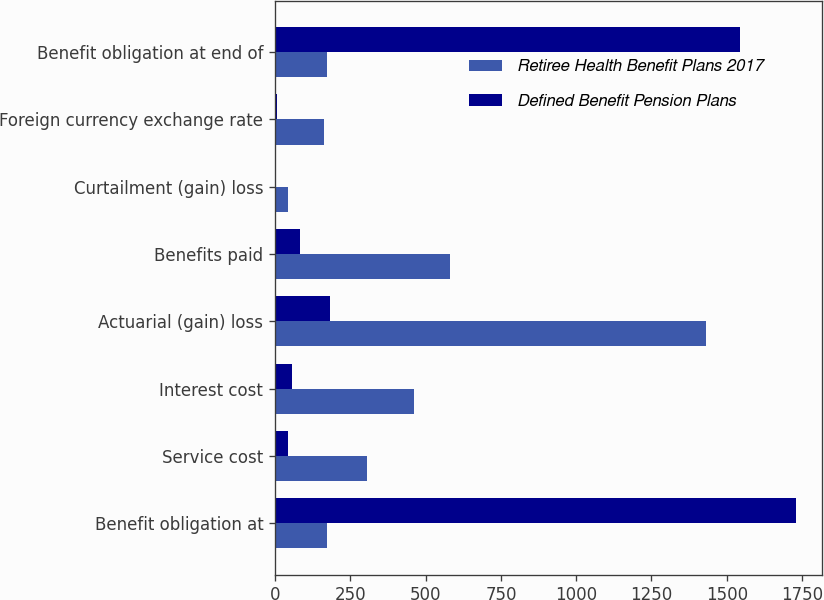<chart> <loc_0><loc_0><loc_500><loc_500><stacked_bar_chart><ecel><fcel>Benefit obligation at<fcel>Service cost<fcel>Interest cost<fcel>Actuarial (gain) loss<fcel>Benefits paid<fcel>Curtailment (gain) loss<fcel>Foreign currency exchange rate<fcel>Benefit obligation at end of<nl><fcel>Retiree Health Benefit Plans 2017<fcel>172.35<fcel>304<fcel>461<fcel>1431.2<fcel>582.1<fcel>43.9<fcel>161.9<fcel>172.35<nl><fcel>Defined Benefit Pension Plans<fcel>1728.5<fcel>41.5<fcel>57.3<fcel>182.8<fcel>82.8<fcel>2.5<fcel>6.2<fcel>1543.9<nl></chart> 